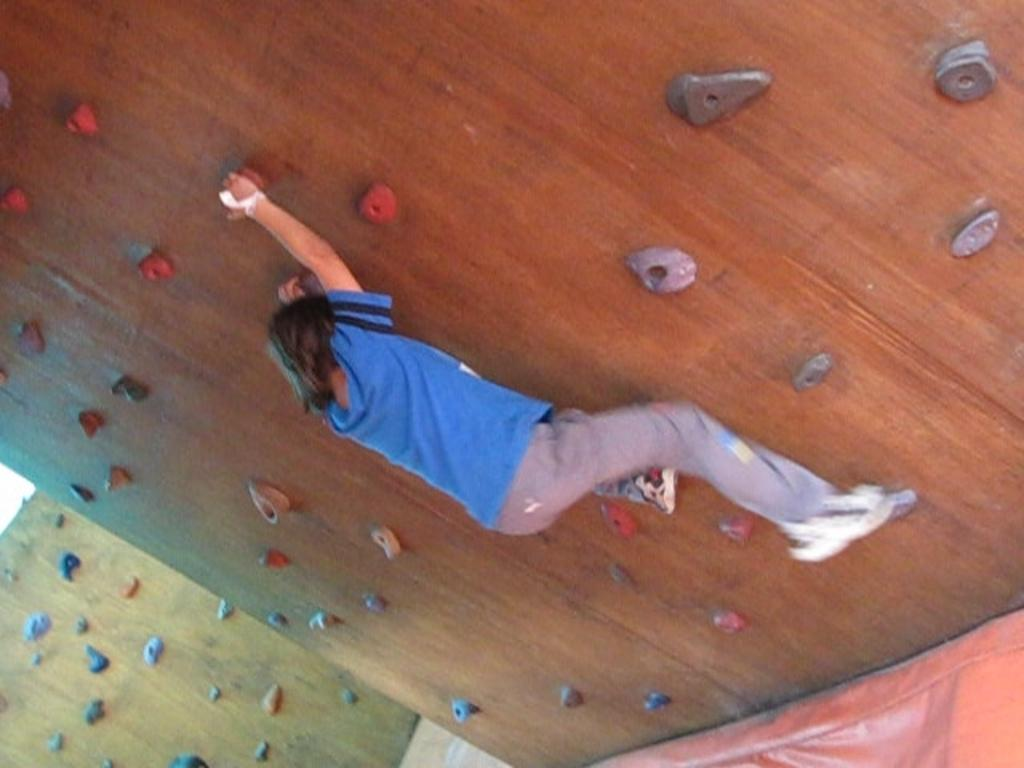What is happening in the image? There is a person in the image who is climbing a wall. What can be observed about the wall in the image? The wall has holders attached to it. What type of table is being used by the organization in the image? There is no table or organization present in the image; it features a person climbing a wall with holders attached to it. 